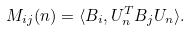<formula> <loc_0><loc_0><loc_500><loc_500>M _ { i j } ( n ) = \langle { B } _ { i } , { U } _ { n } ^ { T } { B } _ { j } { U } _ { n } \rangle .</formula> 